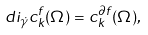Convert formula to latex. <formula><loc_0><loc_0><loc_500><loc_500>d i _ { \dot { \gamma } } c _ { k } ^ { f } ( \Omega ) = c _ { k } ^ { \partial f } ( \Omega ) ,</formula> 